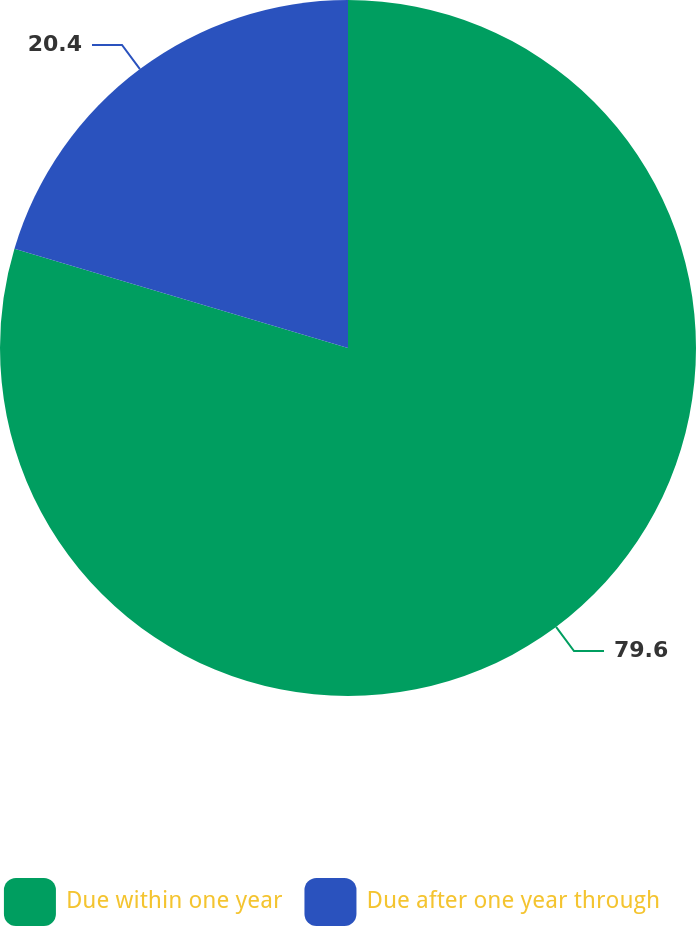Convert chart to OTSL. <chart><loc_0><loc_0><loc_500><loc_500><pie_chart><fcel>Due within one year<fcel>Due after one year through<nl><fcel>79.6%<fcel>20.4%<nl></chart> 